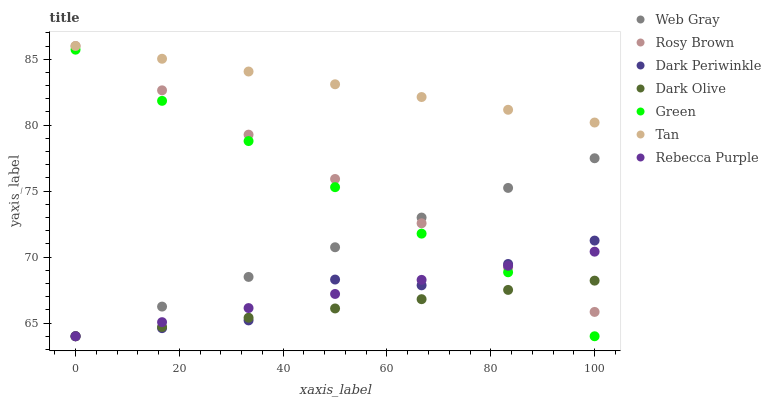Does Dark Olive have the minimum area under the curve?
Answer yes or no. Yes. Does Tan have the maximum area under the curve?
Answer yes or no. Yes. Does Web Gray have the minimum area under the curve?
Answer yes or no. No. Does Web Gray have the maximum area under the curve?
Answer yes or no. No. Is Tan the smoothest?
Answer yes or no. Yes. Is Dark Periwinkle the roughest?
Answer yes or no. Yes. Is Dark Olive the smoothest?
Answer yes or no. No. Is Dark Olive the roughest?
Answer yes or no. No. Does Dark Olive have the lowest value?
Answer yes or no. Yes. Does Tan have the lowest value?
Answer yes or no. No. Does Tan have the highest value?
Answer yes or no. Yes. Does Web Gray have the highest value?
Answer yes or no. No. Is Dark Olive less than Tan?
Answer yes or no. Yes. Is Tan greater than Green?
Answer yes or no. Yes. Does Rebecca Purple intersect Rosy Brown?
Answer yes or no. Yes. Is Rebecca Purple less than Rosy Brown?
Answer yes or no. No. Is Rebecca Purple greater than Rosy Brown?
Answer yes or no. No. Does Dark Olive intersect Tan?
Answer yes or no. No. 